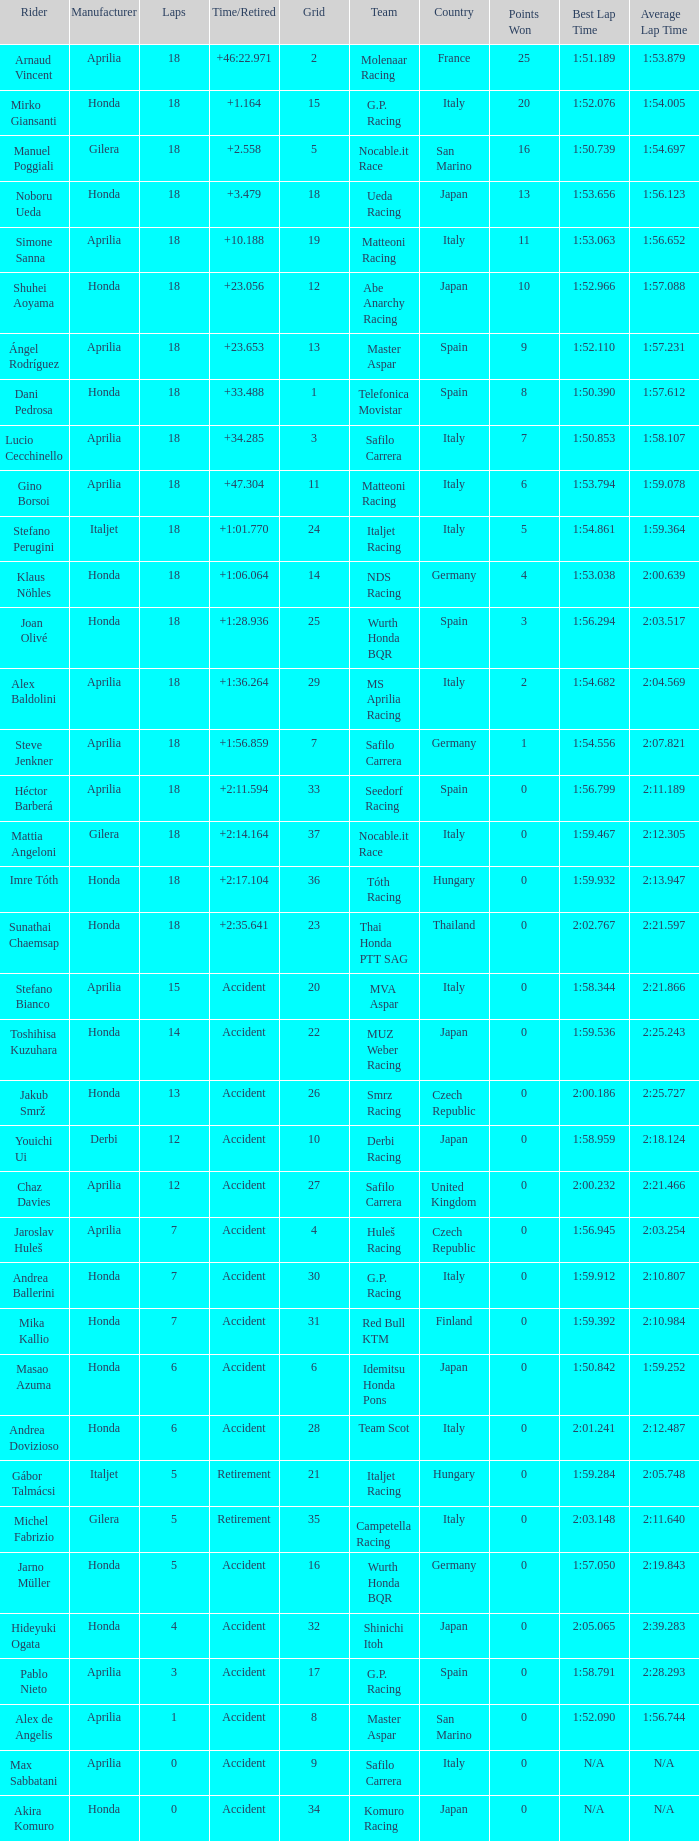What is the average number of laps with an accident time/retired, aprilia manufacturer and a grid of 27? 12.0. 